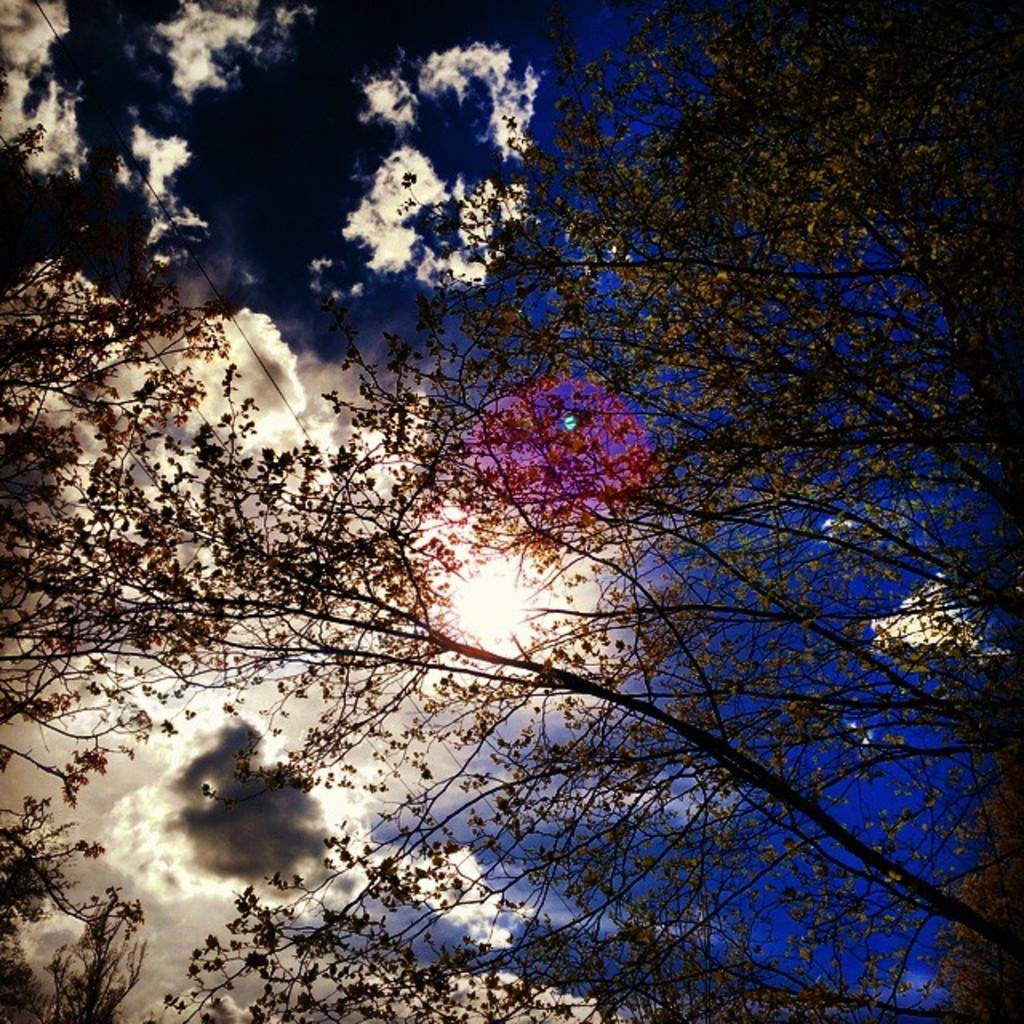What type of vegetation can be seen in the image? There are trees in the image. What part of the natural environment is visible in the image? The sky is visible in the image. What can be observed in the sky? Clouds are present in the sky. Can you see any fish swimming in the image? There are no fish present in the image; it features trees and a sky with clouds. 